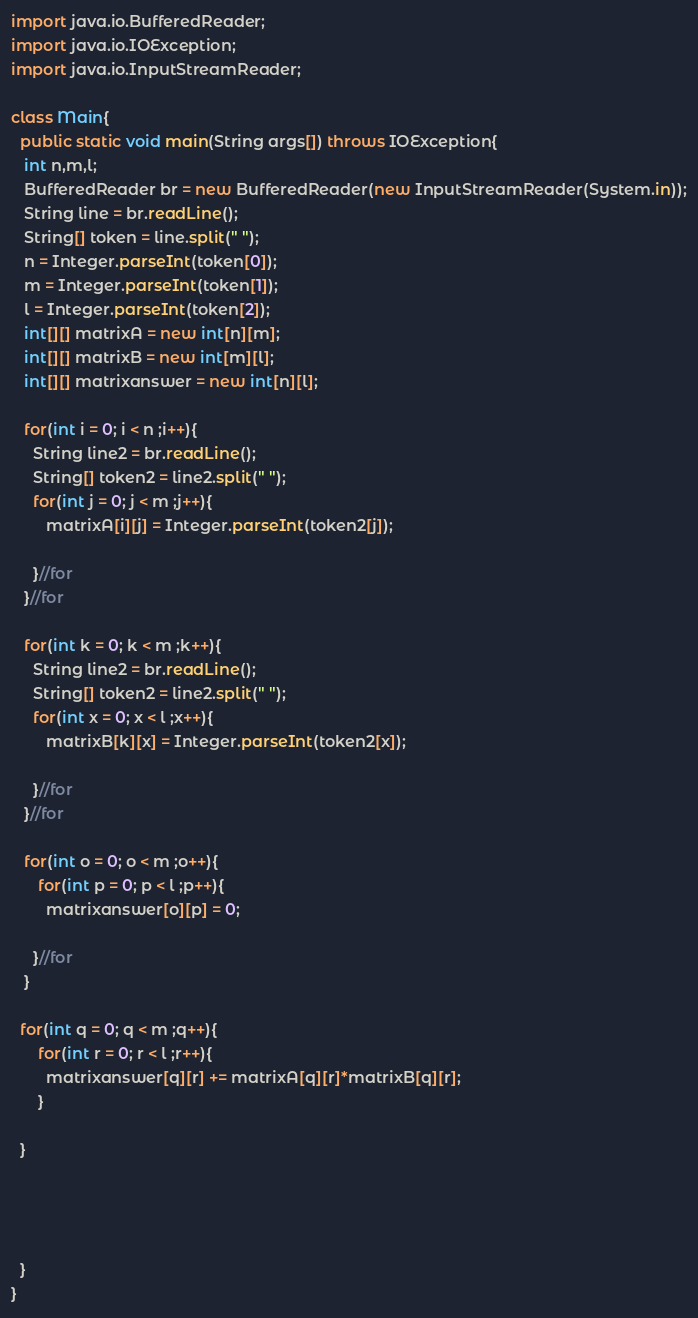Convert code to text. <code><loc_0><loc_0><loc_500><loc_500><_Java_>import java.io.BufferedReader;
import java.io.IOException;
import java.io.InputStreamReader;
 
class Main{
  public static void main(String args[]) throws IOException{
   int n,m,l;
   BufferedReader br = new BufferedReader(new InputStreamReader(System.in));
   String line = br.readLine(); 
   String[] token = line.split(" ");
   n = Integer.parseInt(token[0]);
   m = Integer.parseInt(token[1]);
   l = Integer.parseInt(token[2]); 
   int[][] matrixA = new int[n][m];
   int[][] matrixB = new int[m][l];
   int[][] matrixanswer = new int[n][l]; 
 
   for(int i = 0; i < n ;i++){
     String line2 = br.readLine(); 
     String[] token2 = line2.split(" ");
     for(int j = 0; j < m ;j++){
        matrixA[i][j] = Integer.parseInt(token2[j]);
         
     }//for  
   }//for
 
   for(int k = 0; k < m ;k++){
     String line2 = br.readLine(); 
     String[] token2 = line2.split(" ");
     for(int x = 0; x < l ;x++){
        matrixB[k][x] = Integer.parseInt(token2[x]);
         
     }//for  
   }//for
 
   for(int o = 0; o < m ;o++){
      for(int p = 0; p < l ;p++){
        matrixanswer[o][p] = 0;
         
     }//for 
   }   
 
  for(int q = 0; q < m ;q++){
      for(int r = 0; r < l ;r++){
        matrixanswer[q][r] += matrixA[q][r]*matrixB[q][r];
      }
   
  }
 
    
 
   
  }
}</code> 